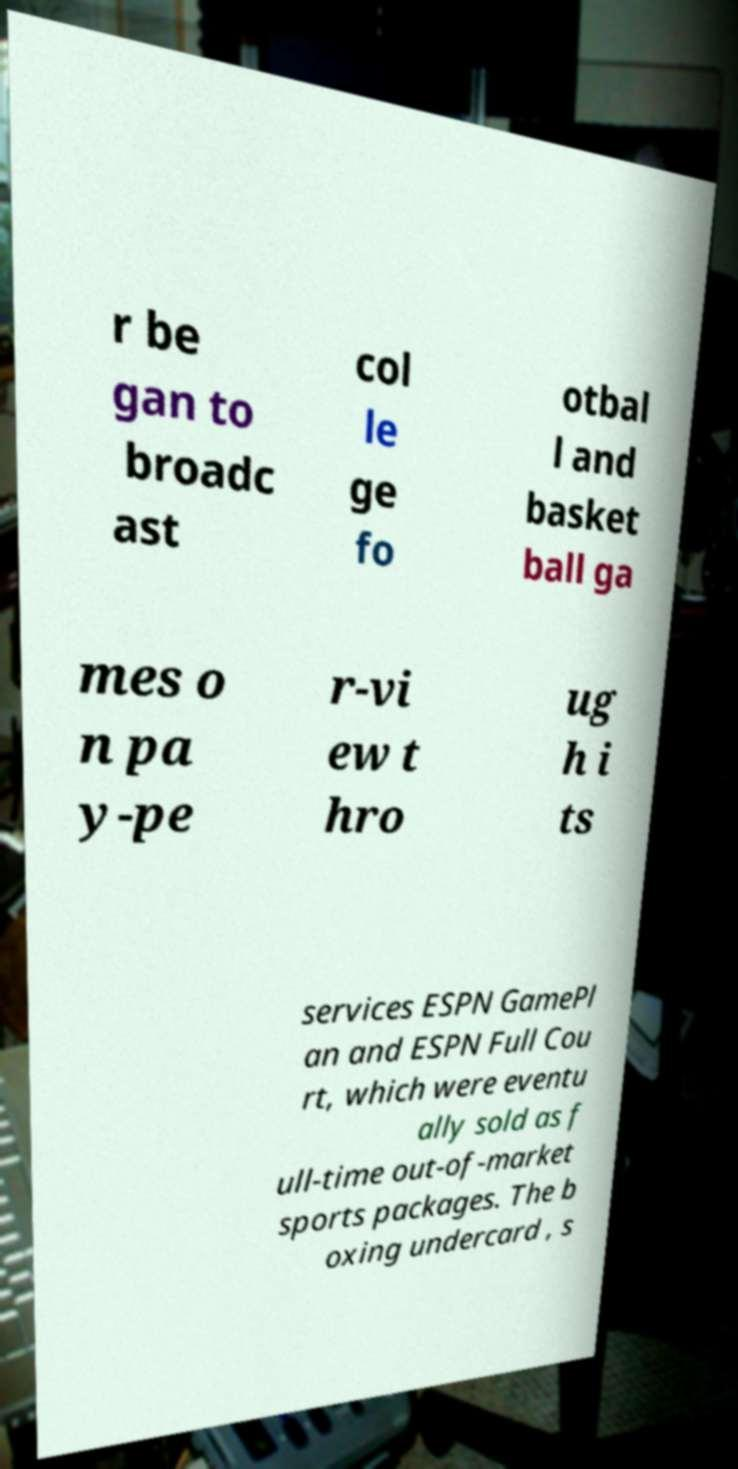Please read and relay the text visible in this image. What does it say? r be gan to broadc ast col le ge fo otbal l and basket ball ga mes o n pa y-pe r-vi ew t hro ug h i ts services ESPN GamePl an and ESPN Full Cou rt, which were eventu ally sold as f ull-time out-of-market sports packages. The b oxing undercard , s 